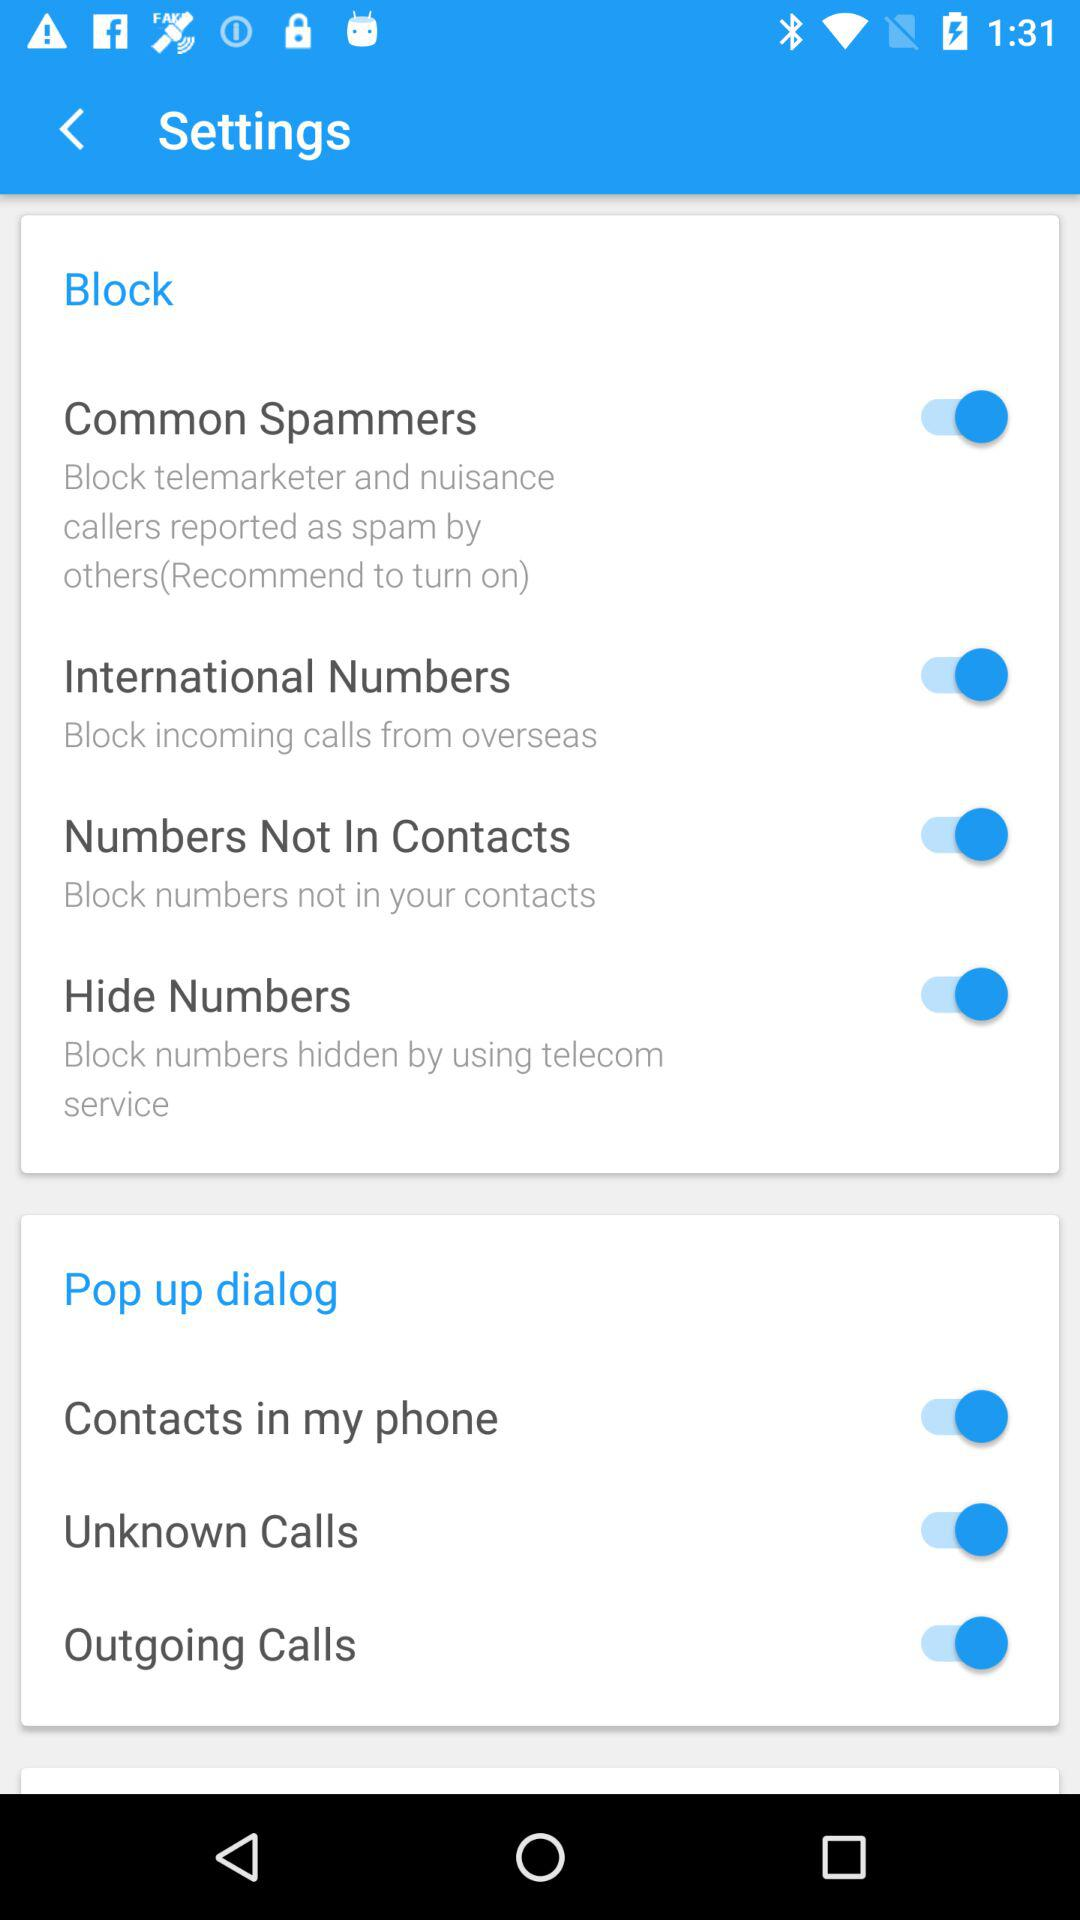What is the status of the "Unknown Calls"? The status of the "Unknown Calls" is "on". 